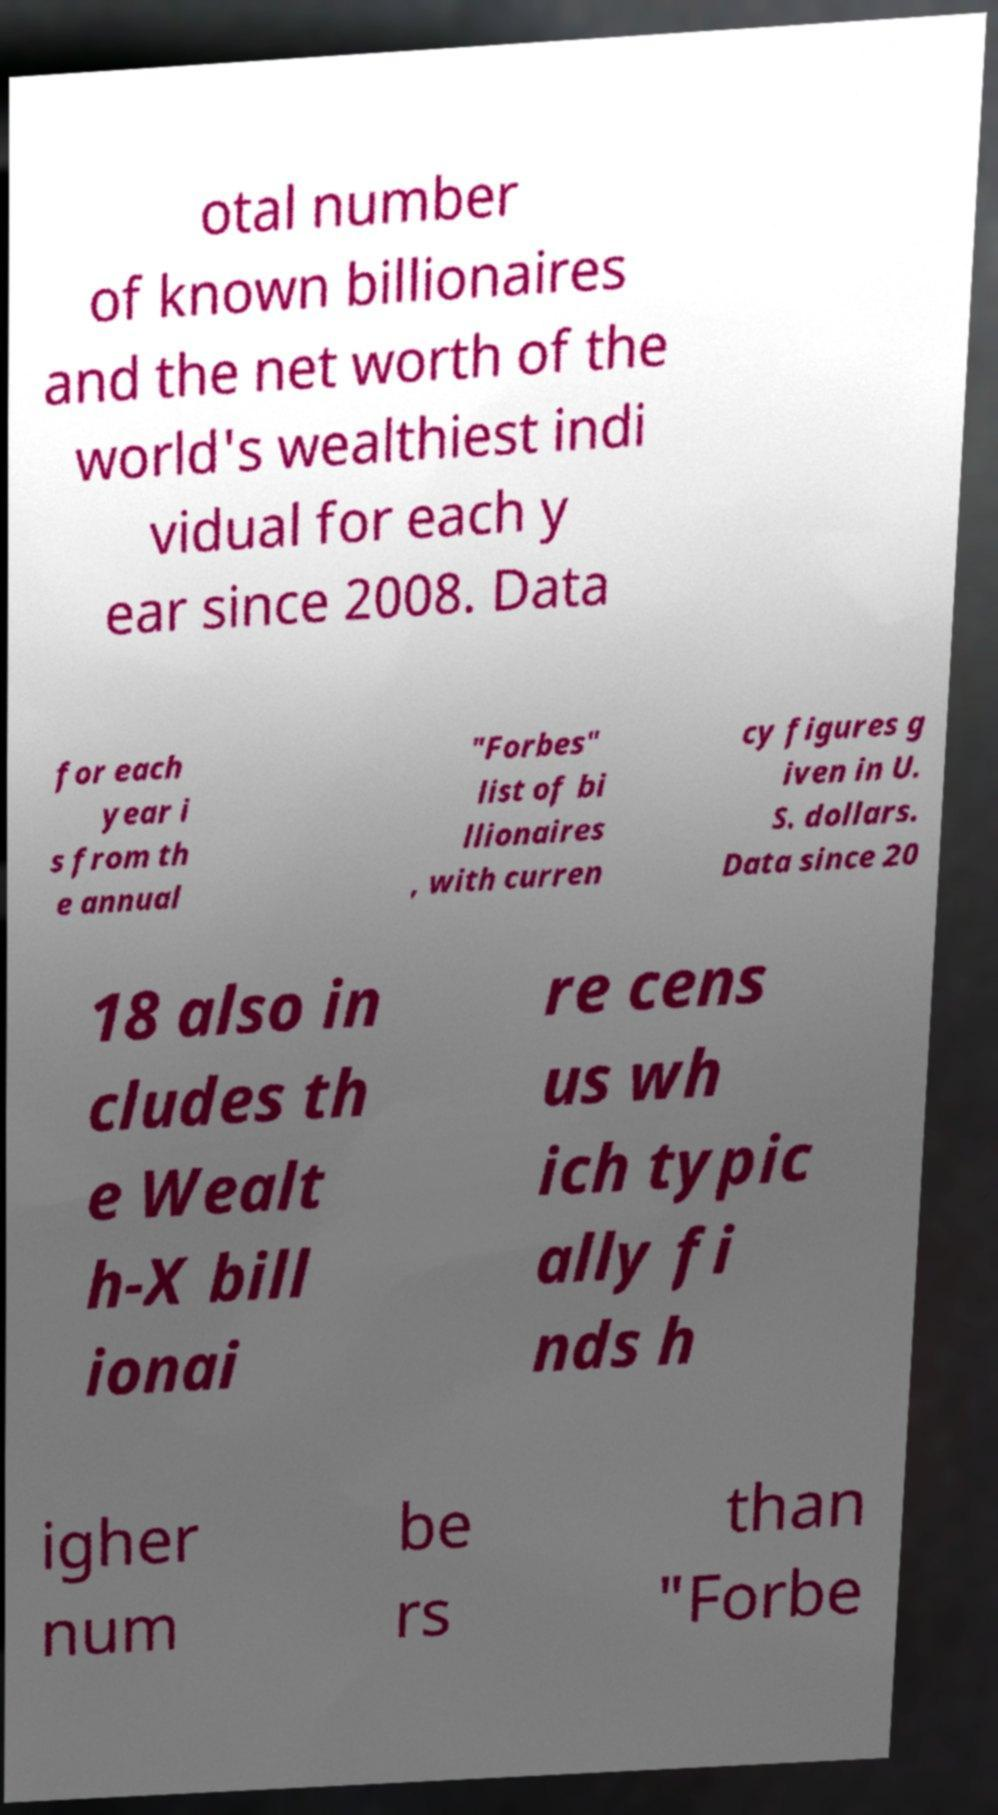Can you read and provide the text displayed in the image?This photo seems to have some interesting text. Can you extract and type it out for me? otal number of known billionaires and the net worth of the world's wealthiest indi vidual for each y ear since 2008. Data for each year i s from th e annual "Forbes" list of bi llionaires , with curren cy figures g iven in U. S. dollars. Data since 20 18 also in cludes th e Wealt h-X bill ionai re cens us wh ich typic ally fi nds h igher num be rs than "Forbe 